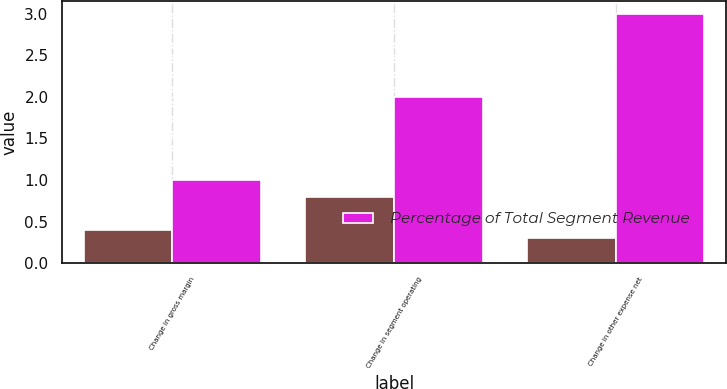Convert chart to OTSL. <chart><loc_0><loc_0><loc_500><loc_500><stacked_bar_chart><ecel><fcel>Change in gross margin<fcel>Change in segment operating<fcel>Change in other expense net<nl><fcel>nan<fcel>0.4<fcel>0.8<fcel>0.3<nl><fcel>Percentage of Total Segment Revenue<fcel>1<fcel>2<fcel>3<nl></chart> 